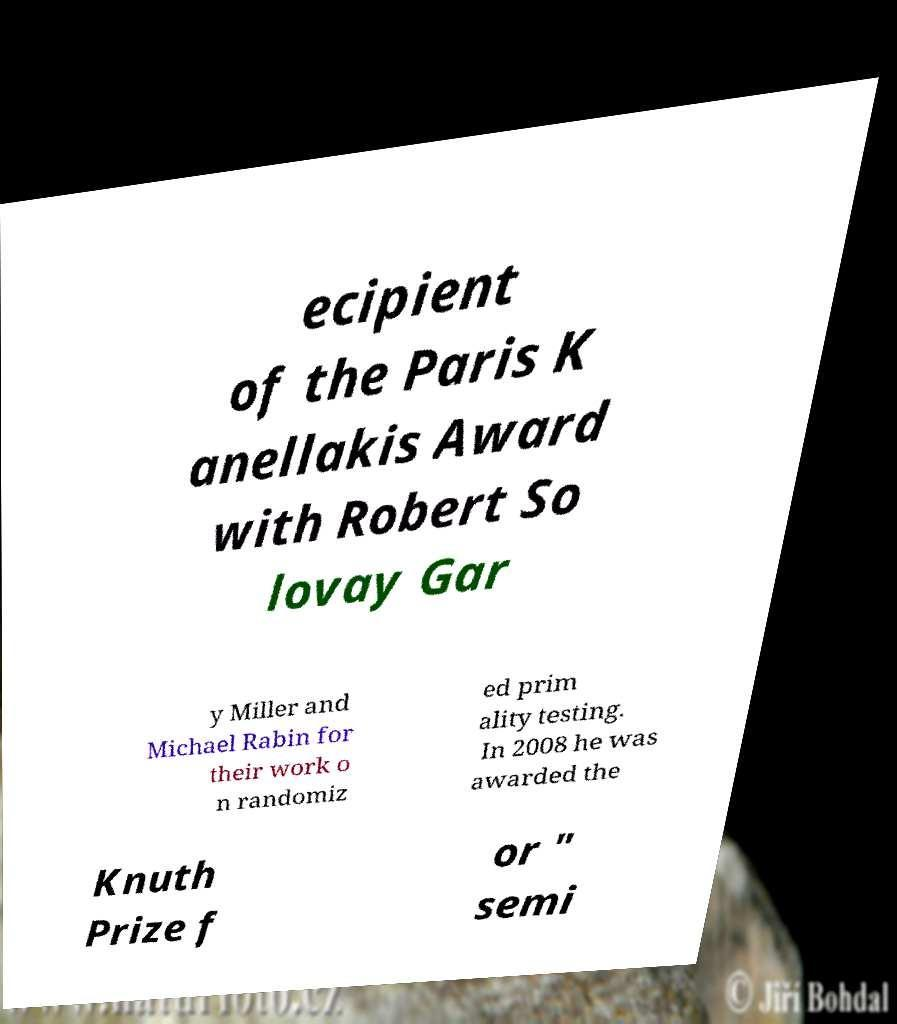Could you extract and type out the text from this image? ecipient of the Paris K anellakis Award with Robert So lovay Gar y Miller and Michael Rabin for their work o n randomiz ed prim ality testing. In 2008 he was awarded the Knuth Prize f or " semi 